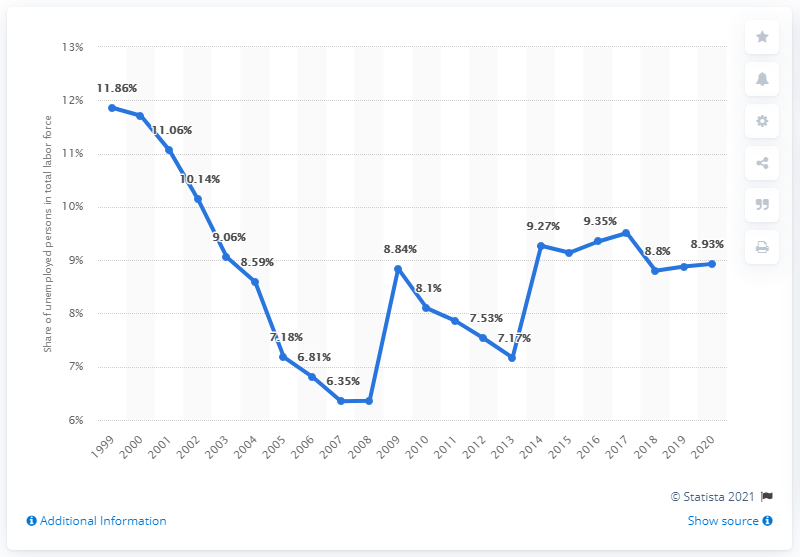Identify some key points in this picture. In 2020, the unemployment rate in Ukraine was 8.93%. 